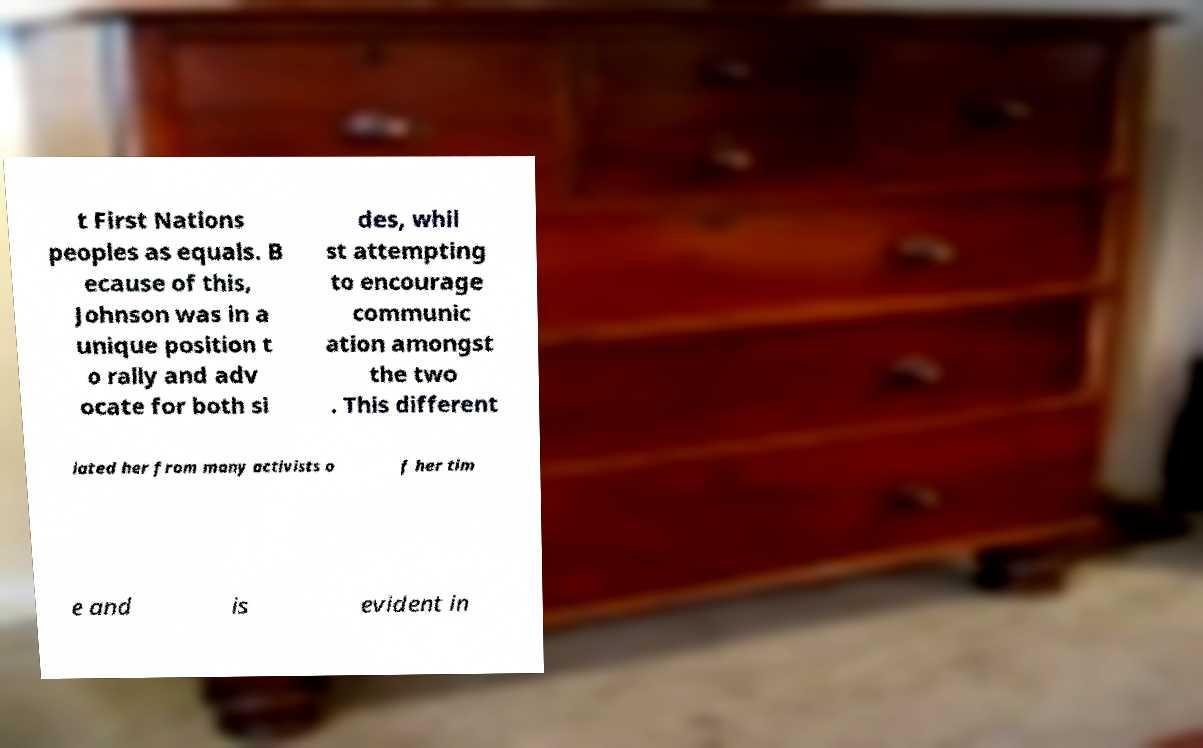Could you extract and type out the text from this image? t First Nations peoples as equals. B ecause of this, Johnson was in a unique position t o rally and adv ocate for both si des, whil st attempting to encourage communic ation amongst the two . This different iated her from many activists o f her tim e and is evident in 